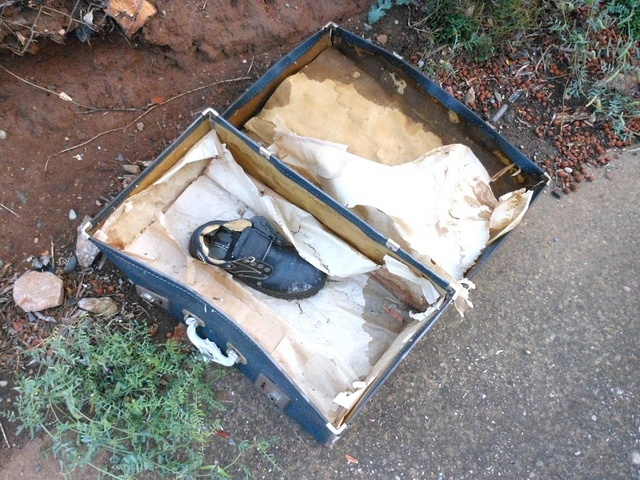Describe the objects in this image and their specific colors. I can see a suitcase in maroon, white, gray, tan, and darkgray tones in this image. 